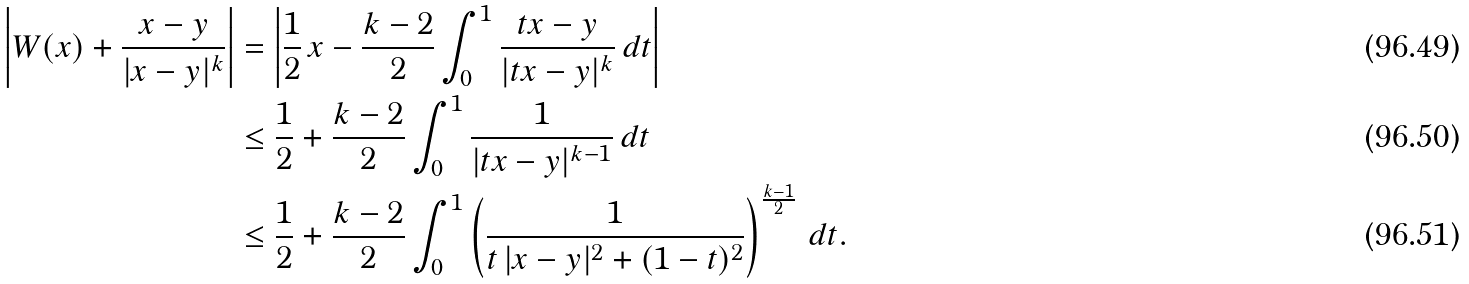<formula> <loc_0><loc_0><loc_500><loc_500>\left | W ( x ) + \frac { x - y } { | x - y | ^ { k } } \right | & = \left | \frac { 1 } { 2 } \, x - \frac { k - 2 } { 2 } \int _ { 0 } ^ { 1 } \frac { t x - y } { | t x - y | ^ { k } } \, d t \right | \\ & \leq \frac { 1 } { 2 } + \frac { k - 2 } { 2 } \int _ { 0 } ^ { 1 } \frac { 1 } { | t x - y | ^ { k - 1 } } \, d t \\ & \leq \frac { 1 } { 2 } + \frac { k - 2 } { 2 } \int _ { 0 } ^ { 1 } \left ( \frac { 1 } { t \, | x - y | ^ { 2 } + ( 1 - t ) ^ { 2 } } \right ) ^ { \frac { k - 1 } { 2 } } \, d t .</formula> 